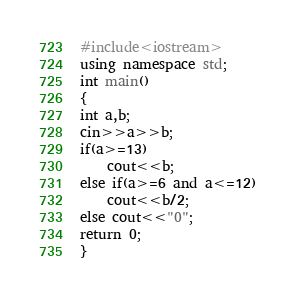Convert code to text. <code><loc_0><loc_0><loc_500><loc_500><_C++_>#include<iostream>
using namespace std;
int main()
{
int a,b;
cin>>a>>b;
if(a>=13)
	cout<<b;
else if(a>=6 and a<=12)
	cout<<b/2;
else cout<<"0";
return 0;
}
</code> 